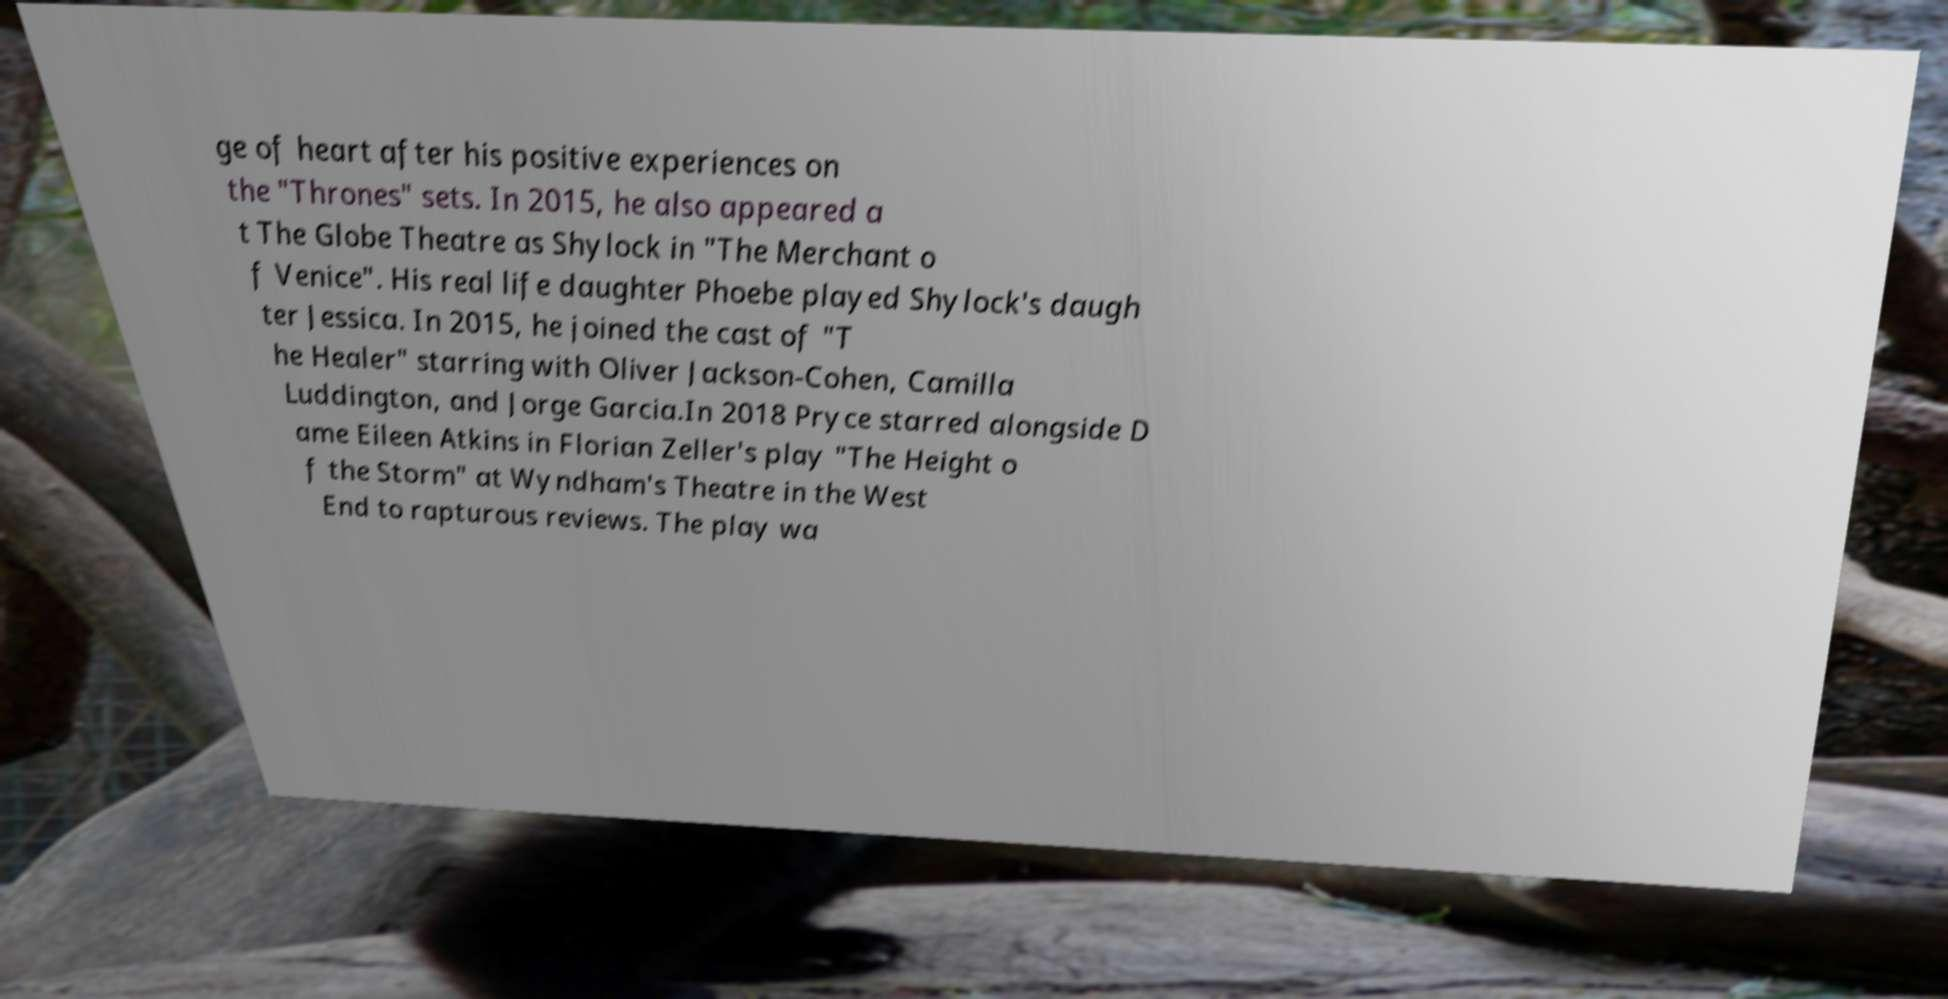For documentation purposes, I need the text within this image transcribed. Could you provide that? ge of heart after his positive experiences on the "Thrones" sets. In 2015, he also appeared a t The Globe Theatre as Shylock in "The Merchant o f Venice". His real life daughter Phoebe played Shylock's daugh ter Jessica. In 2015, he joined the cast of "T he Healer" starring with Oliver Jackson-Cohen, Camilla Luddington, and Jorge Garcia.In 2018 Pryce starred alongside D ame Eileen Atkins in Florian Zeller's play "The Height o f the Storm" at Wyndham's Theatre in the West End to rapturous reviews. The play wa 